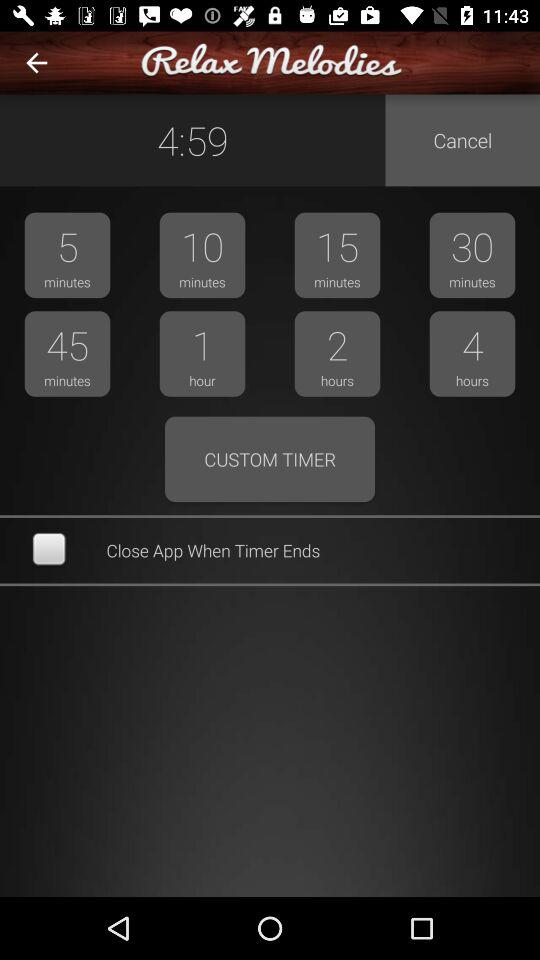How many minutes are there in the shortest available timer?
Answer the question using a single word or phrase. 5 